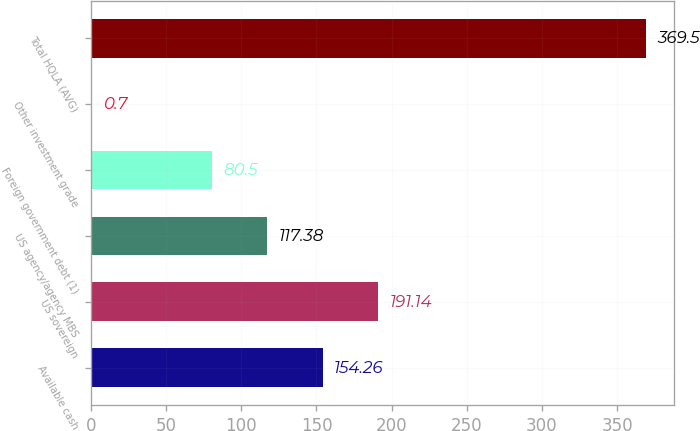Convert chart. <chart><loc_0><loc_0><loc_500><loc_500><bar_chart><fcel>Available cash<fcel>US sovereign<fcel>US agency/agency MBS<fcel>Foreign government debt (1)<fcel>Other investment grade<fcel>Total HQLA (AVG)<nl><fcel>154.26<fcel>191.14<fcel>117.38<fcel>80.5<fcel>0.7<fcel>369.5<nl></chart> 